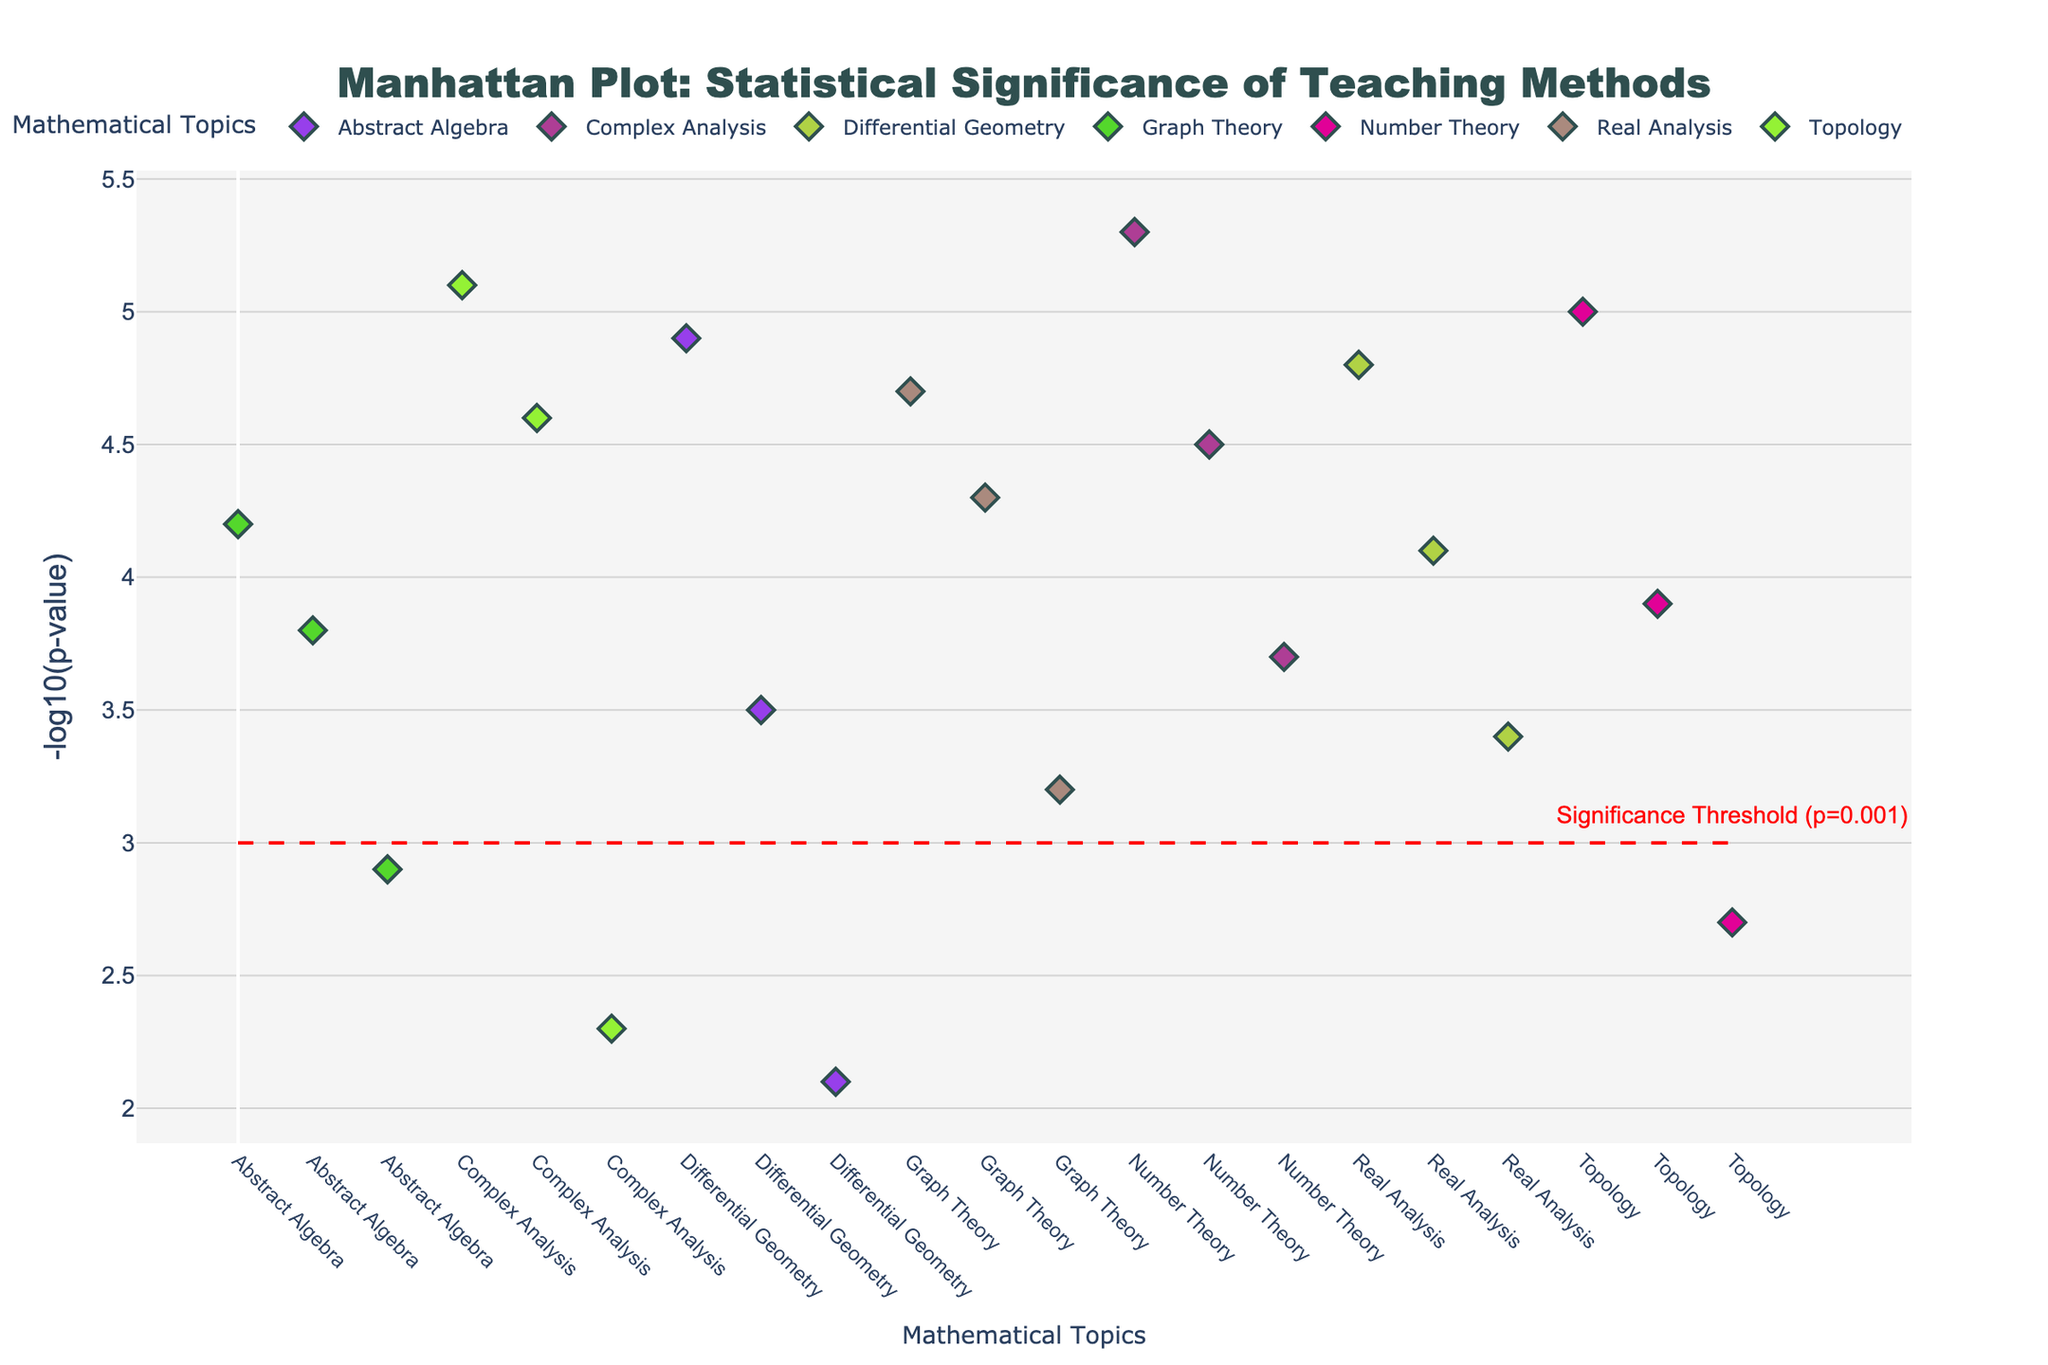Which teaching method in Topology has the highest -log10(p-value)? In the plot, look for the markers under the "Topology" category and identify the one with the highest peak along the y-axis. The method corresponding to this peak is Problem-Based Learning at -log10(p-value) of 5.1.
Answer: Problem-Based Learning How many teaching methods in Graph Theory have -log10(p-value) greater than 3? Identify the markers under the "Graph Theory" category and count those which have a vertical position above the y = 3 threshold line. Both Interactive Visualization and Peer Instruction are above 3.
Answer: 2 Which mathematical topic has the most significant teaching method based on -log10(p-value)? Look for the highest peak in the entire plot, regardless of the mathematical topic. The highest -log10(p-value) is 5.3, which corresponds to Project-Based Learning in Complex Analysis.
Answer: Complex Analysis Compare the highest -log10(p-value) for Complex Analysis and Real Analysis. Which is higher and by how much? Identify the highest peaks in both "Complex Analysis" and "Real Analysis", which are 5.3 and 4.7 respectively. Calculate the difference between the two values: 5.3 - 4.7 = 0.6.
Answer: Complex Analysis, by 0.6 Is there any teaching method in Abstract Algebra that does not meet the significance threshold of p = 0.001? Look at the markers under "Abstract Algebra" and determine if any are below the y = 3 threshold line. Traditional Homework is below the threshold at -log10(p-value) of 2.1.
Answer: Yes What teaching method across all topics appears exactly on the significance threshold line? Find the marker that is placed exactly on the horizontal line at y = 3. In Graph Theory, Flipped Classroom has -log10(p-value) of 2.9, which is very close but does not meet the threshold exactly. Lecture Demonstrations in Number Theory also comes close but is slightly above at -log10(p-value) 2.7. However, no method is precisely on the line, so the answer would be none.
Answer: None How many mathematical topics have at least one teaching method with -log10(p-value) greater than 4.5? For each mathematical topic on the x-axis, count if there is a marker that exceeds the value of 4.5 on the y-axis. These topics are Topology, Abstract Algebra, Real Analysis, Complex Analysis, Differential Geometry, and Number Theory.
Answer: 6 Calculate the average -log10(p-value) for all teaching methods in Differential Geometry. Sum the -log10(p-value) values for all methods in Differential Geometry (4.8, 4.1, 3.4), and divide by the number of methods: (4.8 + 4.1 + 3.4) / 3 = 4.1.
Answer: 4.1 Which teaching method has the second highest -log10(p-value) in the entire plot? Identify the two highest peaks in the plot. The highest is Project-Based Learning in Complex Analysis (5.3), and the second highest is Problem-Based Learning in Topology (5.1).
Answer: Problem-Based Learning in Topology 